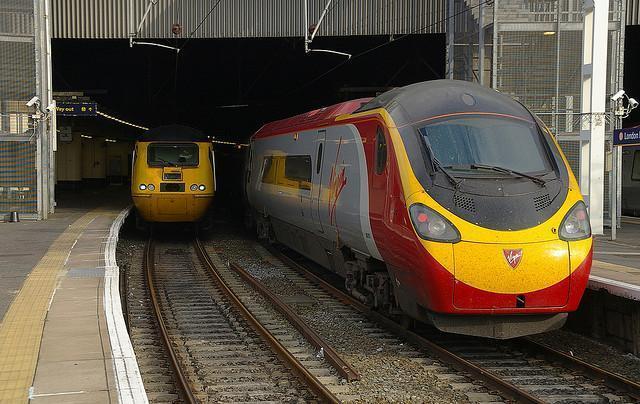How many trains are seen?
Give a very brief answer. 2. How many windshield wipers does the train have?
Give a very brief answer. 2. How many trains are in the photo?
Give a very brief answer. 2. 